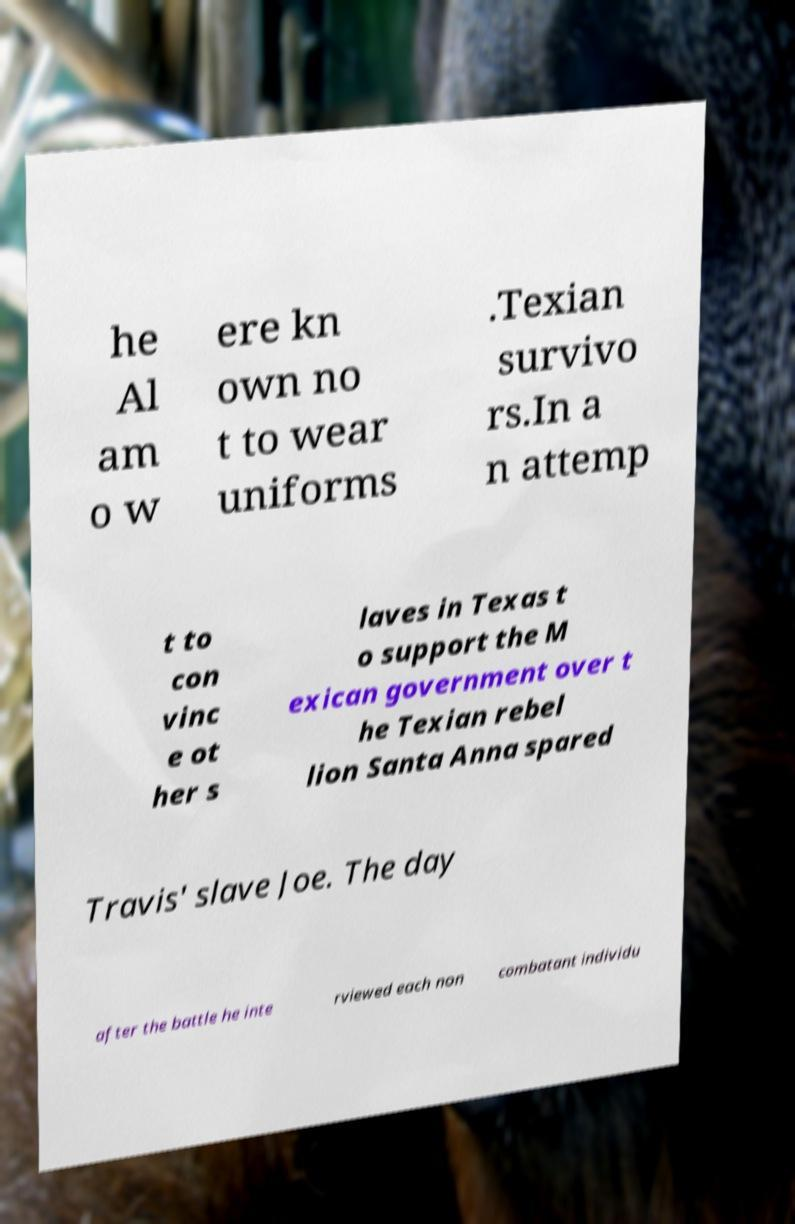Please read and relay the text visible in this image. What does it say? he Al am o w ere kn own no t to wear uniforms .Texian survivo rs.In a n attemp t to con vinc e ot her s laves in Texas t o support the M exican government over t he Texian rebel lion Santa Anna spared Travis' slave Joe. The day after the battle he inte rviewed each non combatant individu 